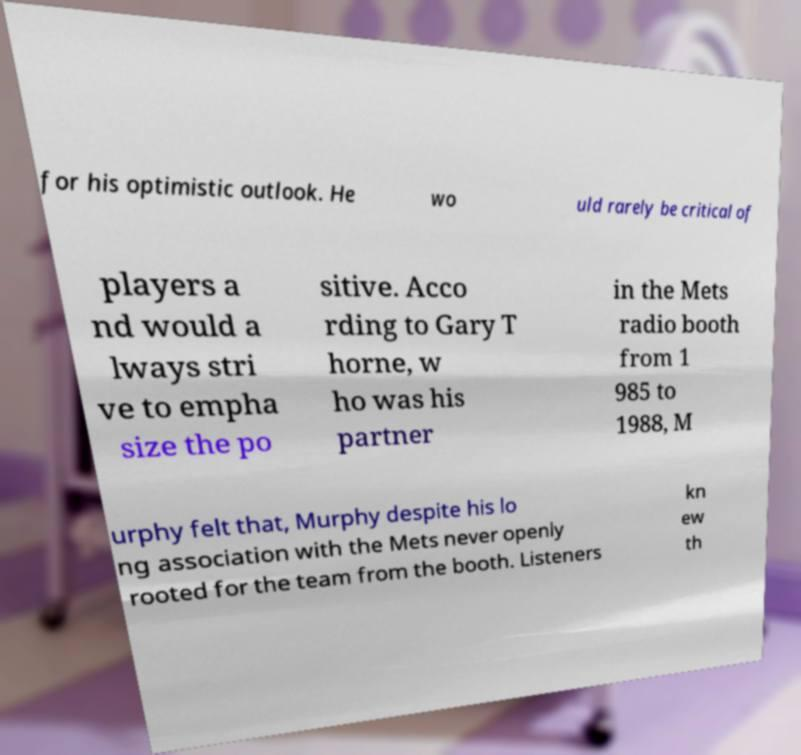For documentation purposes, I need the text within this image transcribed. Could you provide that? for his optimistic outlook. He wo uld rarely be critical of players a nd would a lways stri ve to empha size the po sitive. Acco rding to Gary T horne, w ho was his partner in the Mets radio booth from 1 985 to 1988, M urphy felt that, Murphy despite his lo ng association with the Mets never openly rooted for the team from the booth. Listeners kn ew th 